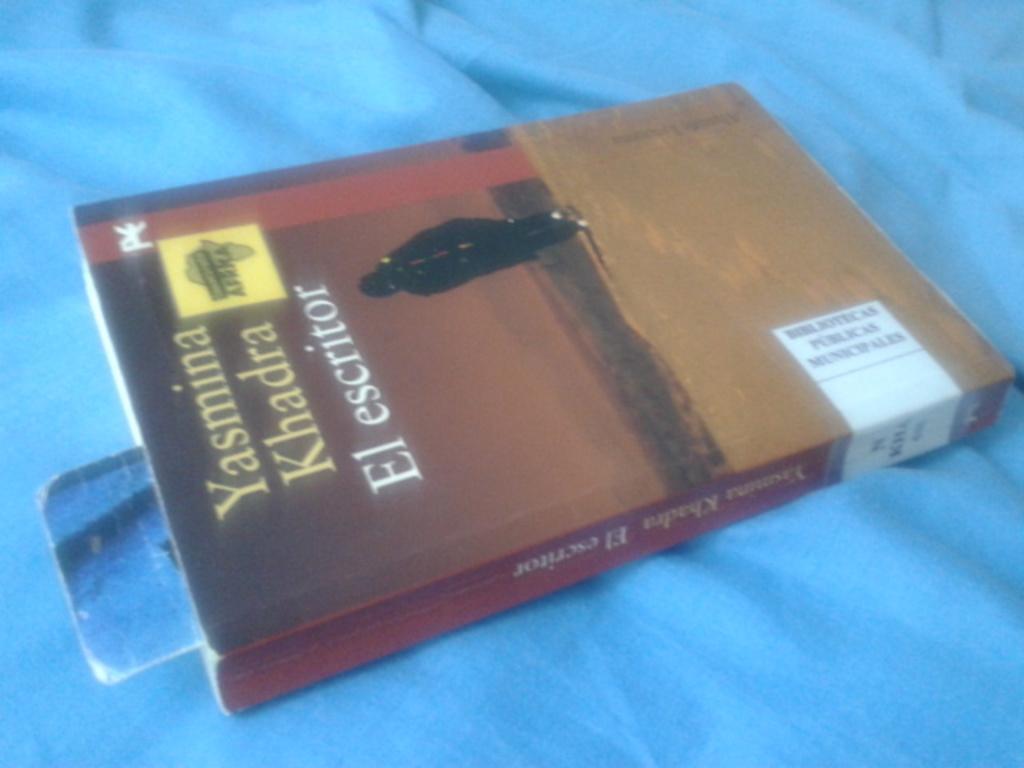Can you describe this image briefly? In the picture we can see a book with a cover, name on it as Yasima Khadra el escritoire, the book places on the blue cover cloth. 